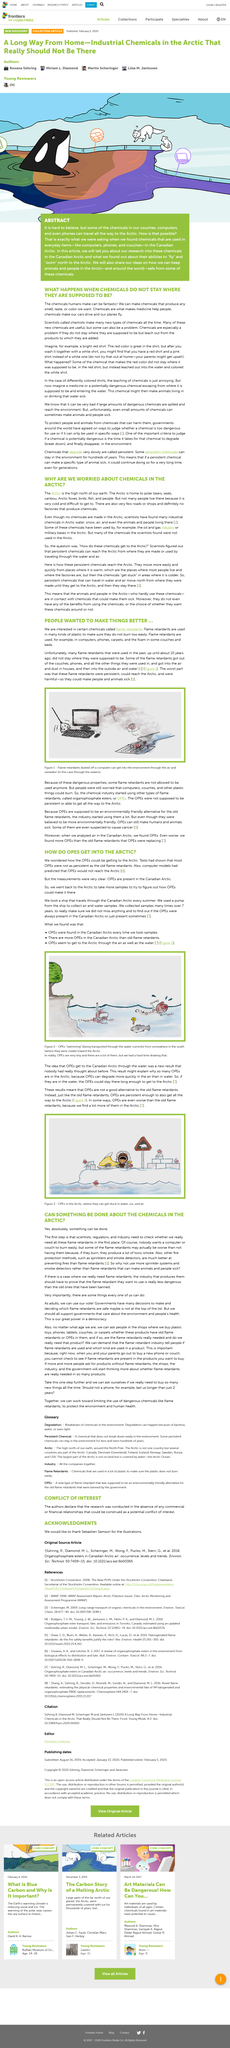Point out several critical features in this image. If you wash a bright red shirt together with a white shirt, it is likely that you will end up with a red shirt and a pink shirt instead of a white one. Some suspected OPEs have been linked to the development of cancer. Organophosphate ester is commonly referred to as OPE. Flame retardants are used in plastics to prevent them from easily burning or igniting. OPEs are not a good alternative to traditional flame retardants. 